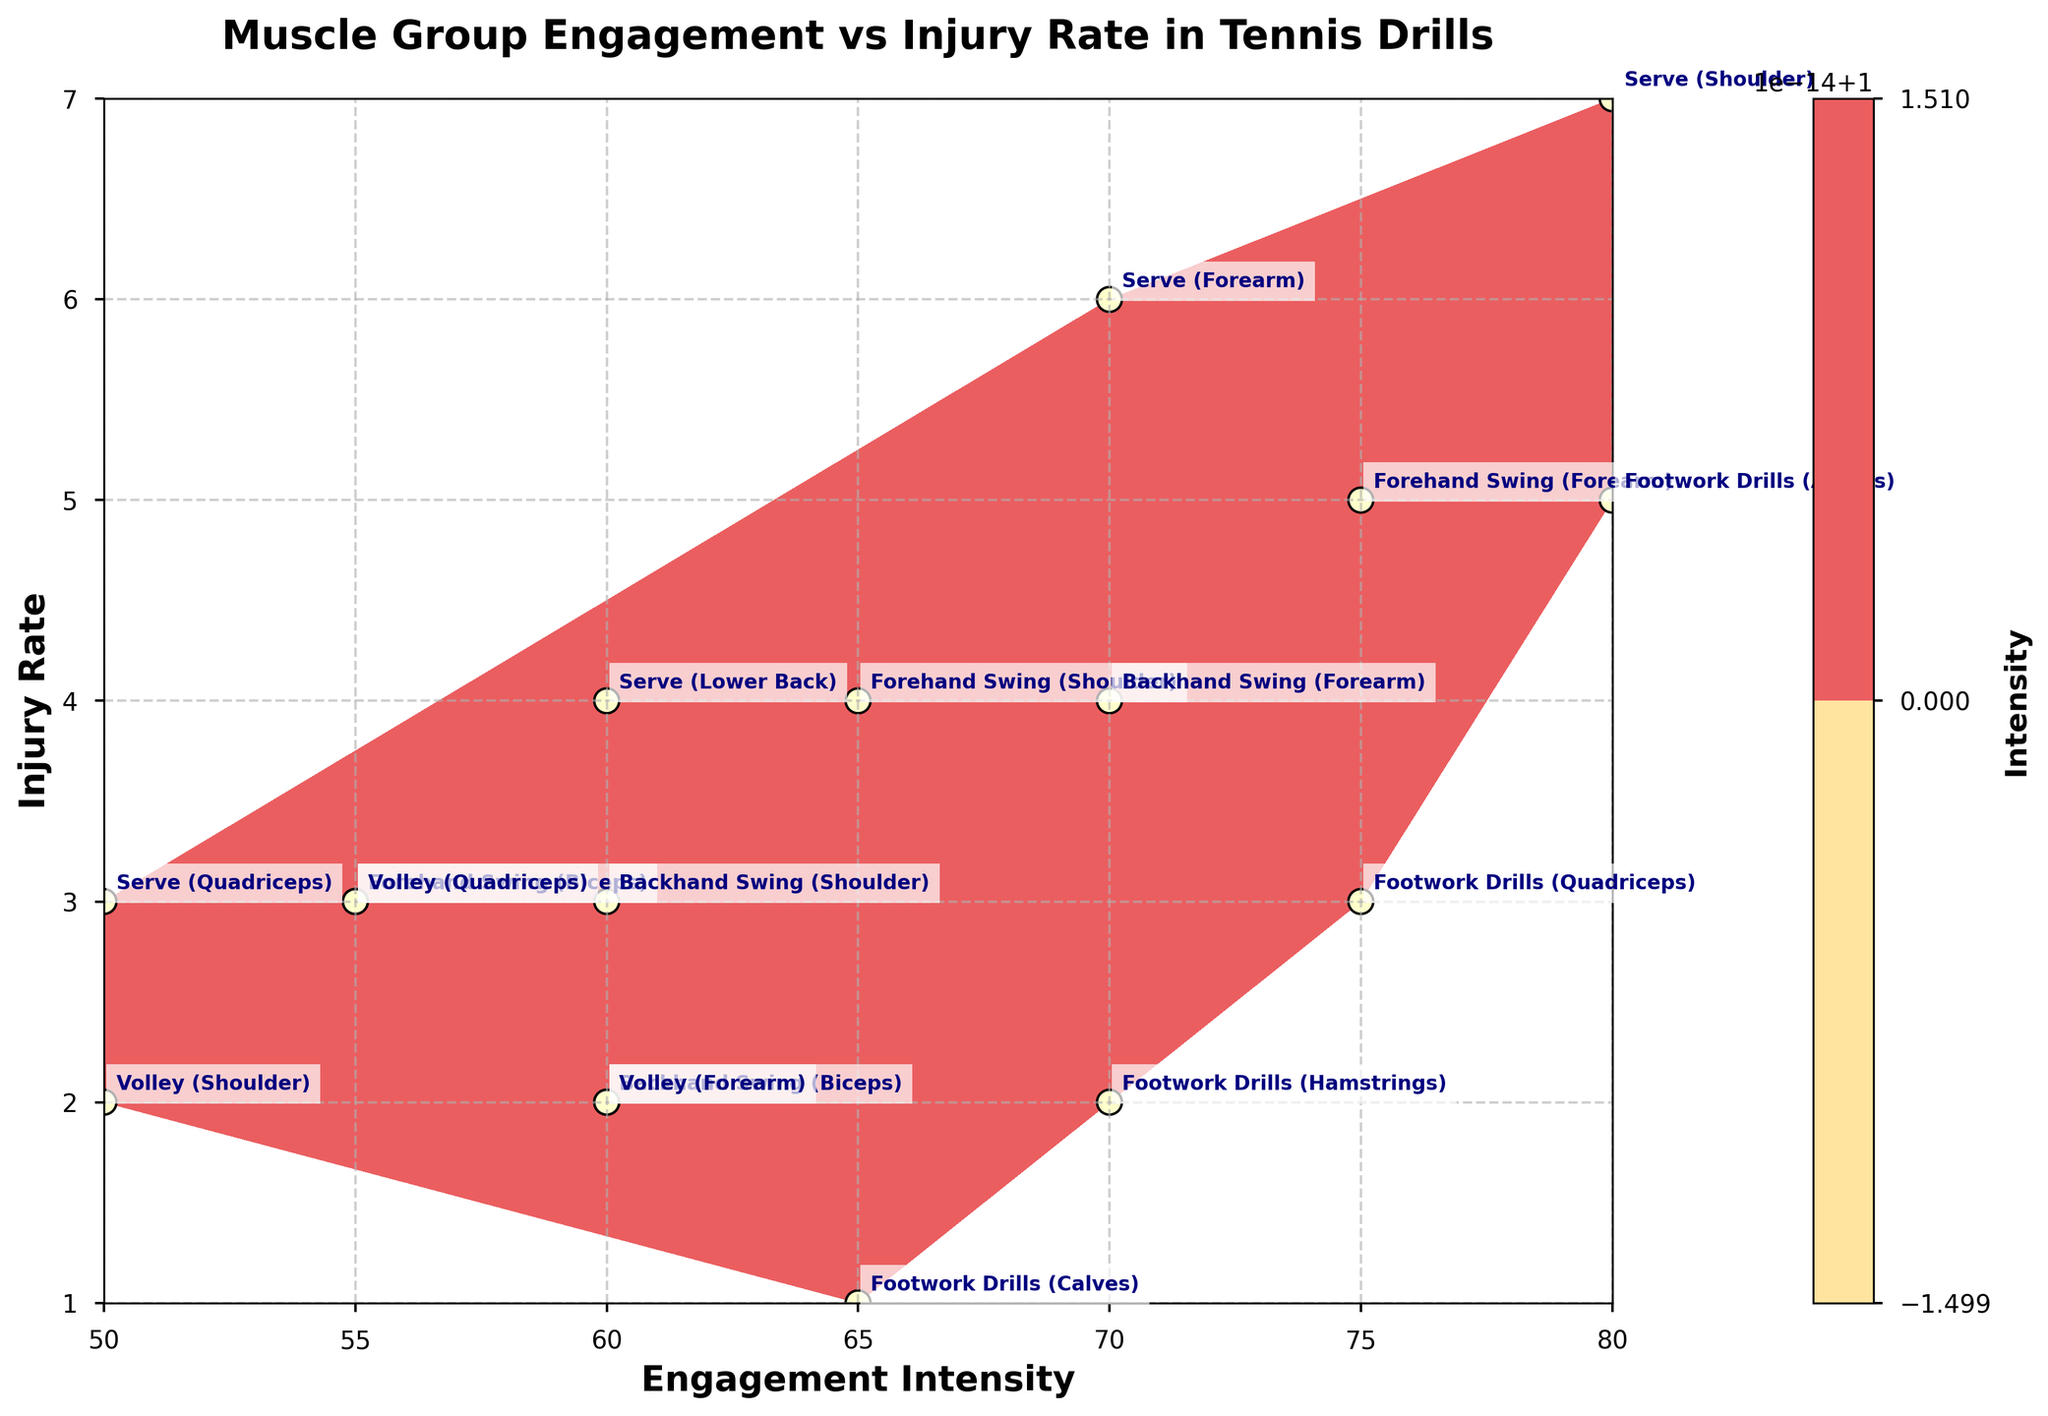What is the title of the figure? The title is typically displayed at the top of the figure in larger, bold font. Here, it states the main topic of the plot, found above the plotted data.
Answer: Muscle Group Engagement vs Injury Rate in Tennis Drills How many data points are there in the plot? To find the number of data points, count each unique combination of 'Engagement Intensity' and 'Injury Rate' scattered across the plot.
Answer: 15 Which drill and muscle group combination has the highest injury rate? By looking at the y-axis for the highest injury rate value and identifying the associated data point label, we can determine which drill and muscle group is involved.
Answer: Serve (Shoulder) What is the engagement intensity for the backhand swing affecting the biceps? Locate the data point labeled 'Backhand Swing (Biceps)' and read the corresponding x-axis value for engagement intensity.
Answer: 60 What is the overall trend between engagement intensity and injury rate shown in the plot? To see the trend, observe the general direction in which data points are clustered and how they follow the contour lines. Generally, a higher engagement intensity seems correlated with a higher injury rate.
Answer: Higher engagement intensity, higher injury rate How many muscle groups are involved in the Serve drill? Identify and count each 'Serve' data point with its corresponding muscle group in the labels.
Answer: 4 Which muscle group in the Footwork Drills has the lowest injury rate, and what's its engagement intensity? Locate the 'Footwork Drills' data points and compare their injury rates. Then, read the engagement intensity of the one with the lowest rate.
Answer: Calves with engagement intensity of 65 What is the average engagement intensity for all the Forearm muscle group data points? Sum the engagement intensities for 'Forearm' across all drills and divide by the number of such data points. Calculations: (75+70+60)/3 = 205/3 = 68.3
Answer: 68.3 Which drill appears to be the riskiest in terms of injury rate? Identify the drill with the highest concentration of high injury rate data points by examining the y-axis values across the plot.
Answer: Serve Compare the injury rate between the Quadriceps in Serve and in Footwork Drills. Which one is more injury-prone? Look at the y-axis values for both 'Serve (Quadriceps)' and 'Footwork Drills (Quadriceps)' data points and compare them.
Answer: Serve (Quadriceps) with an injury rate of 3 